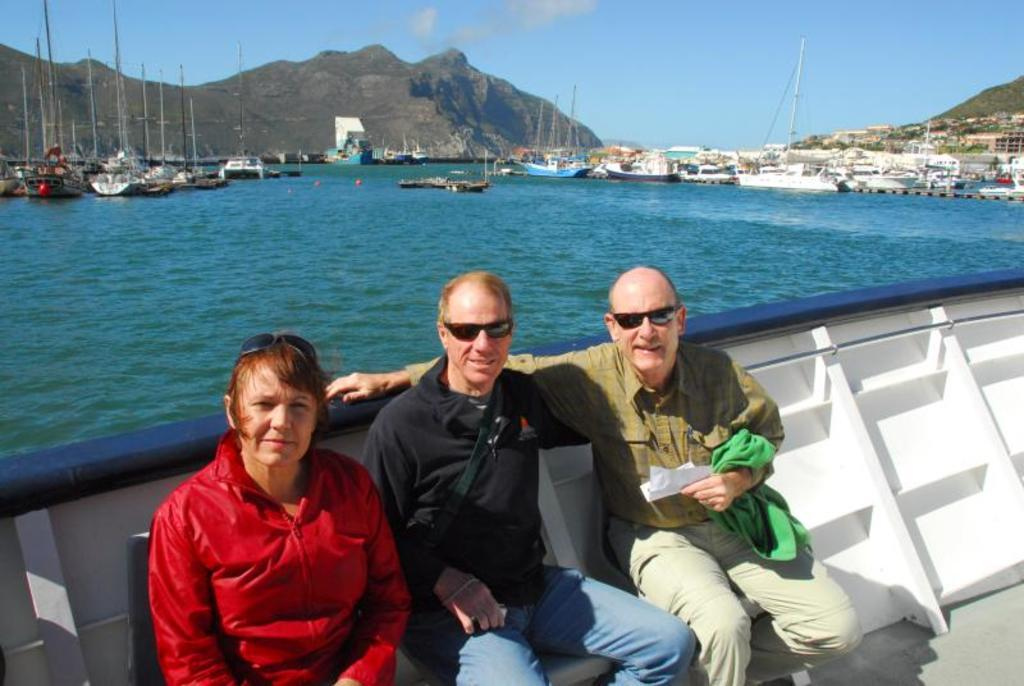How many people are sitting in the image? There are three people sitting in the image. What can be seen in the background of the image? There is water, boats, a hill, and the sky visible in the background. Can you describe the water in the image? The water is visible in the background, and there are boats in it. What type of landscape feature is present in the background? There is a hill in the background. What part of the natural environment is visible in the image? The sky is visible in the background. What type of slave is depicted in the image? There is no slave depicted in the image; it features three people sitting and a background with water, boats, a hill, and the sky. What color is the sock on the person's foot in the image? There are no socks visible in the image, as the people are sitting and their feet are not shown. 